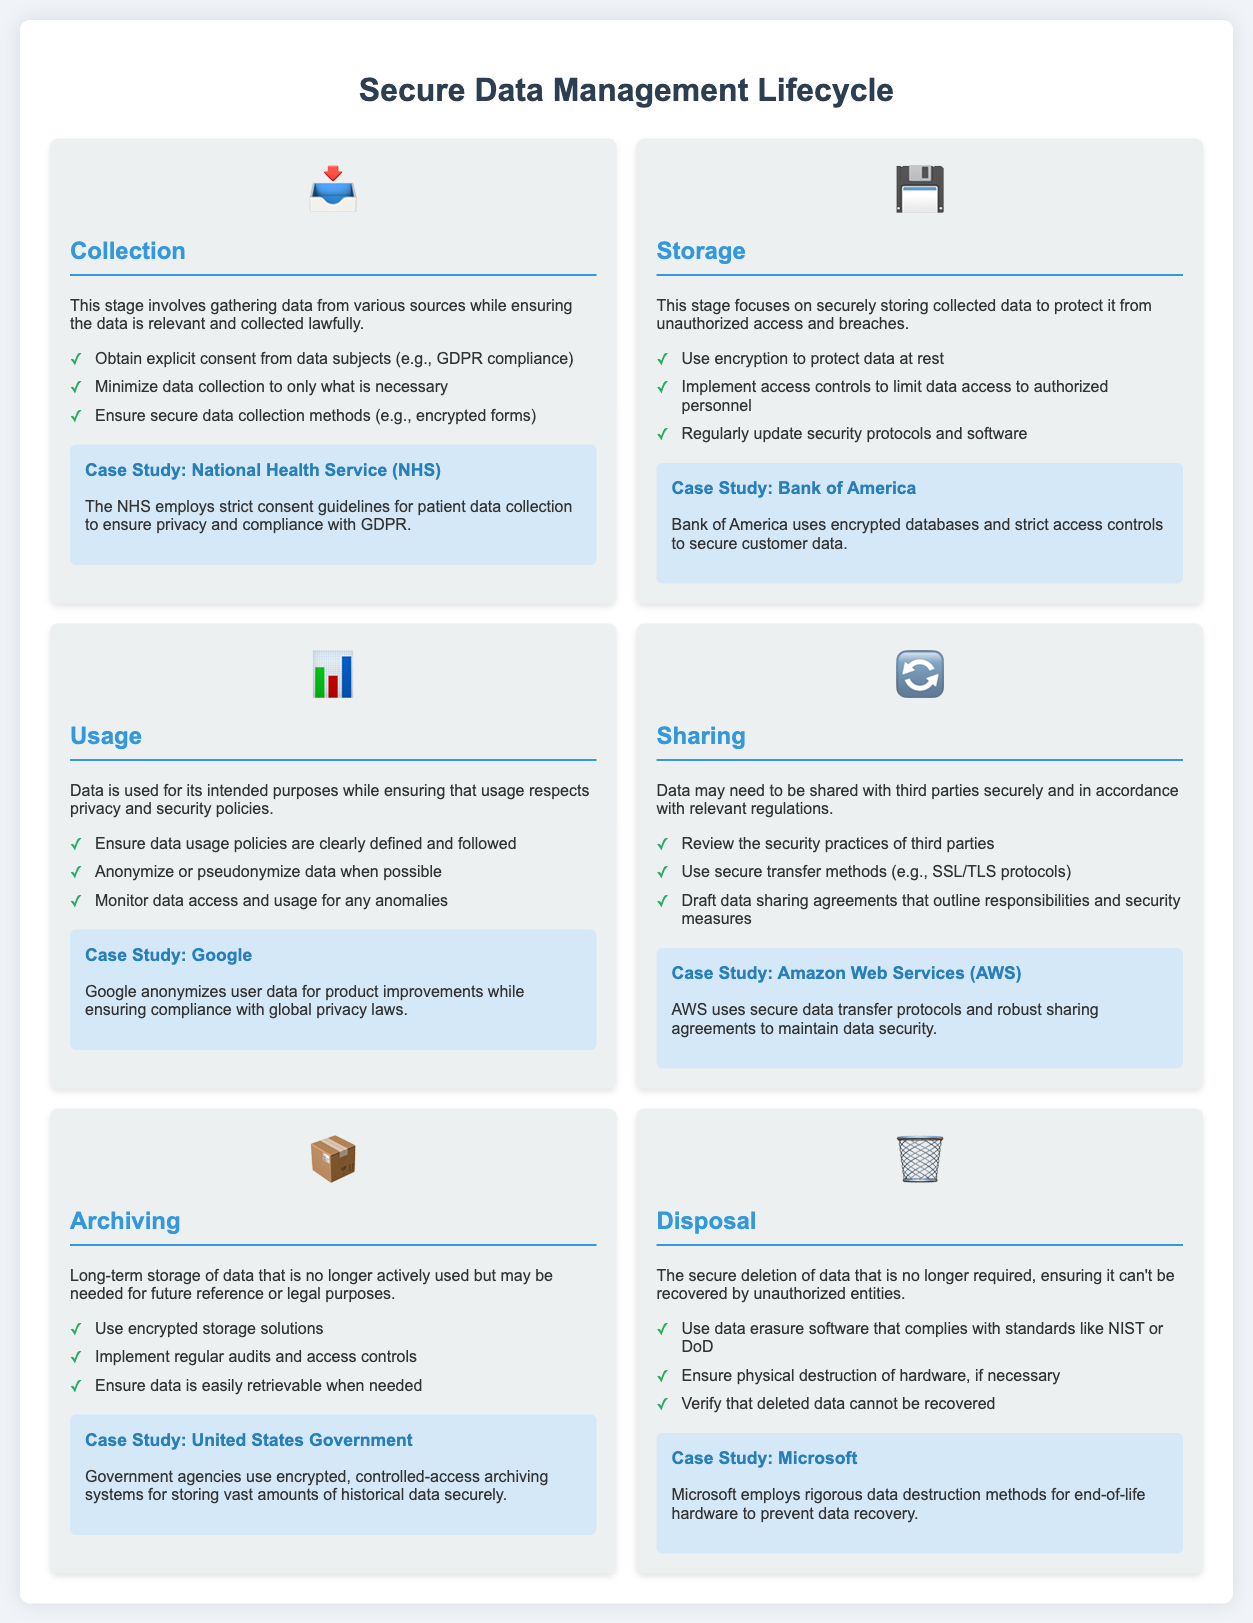What is the first stage of the data management lifecycle? The first stage is clearly stated at the beginning of the infographic as Collection.
Answer: Collection What icon represents the Sharing stage? Each stage has an icon representing it, and the Sharing stage icon is a circular arrow.
Answer: 🔄 Which organization employs strict consent guidelines for patient data collection? The case study mentions the NHS, which is known for these guidelines.
Answer: National Health Service (NHS) What is a best practice for data disposal? The document lists best practices for each stage; for disposal, it recommends using data erasure software that complies with standards.
Answer: Data erasure software What is a key focus during the Storage stage? The explanation of this stage outlines that the main focus is securely storing collected data to protect it from unauthorized access.
Answer: Securely storing data Which company uses encrypted databases to secure customer data? A case study within the infographic highlights a banking institution known for its secure methods.
Answer: Bank of America How does Google ensure compliance with global privacy laws? The document specifies that Google anonymizes user data as part of its privacy compliance strategy.
Answer: Anonymizes user data What stage involves the secure deletion of data? The infographic clearly defines the Disposal stage as being responsible for secure deletion.
Answer: Disposal Which government entity uses encrypted archiving systems for historical data? The case study points out that government agencies utilize specific methods for secure archiving.
Answer: United States Government 